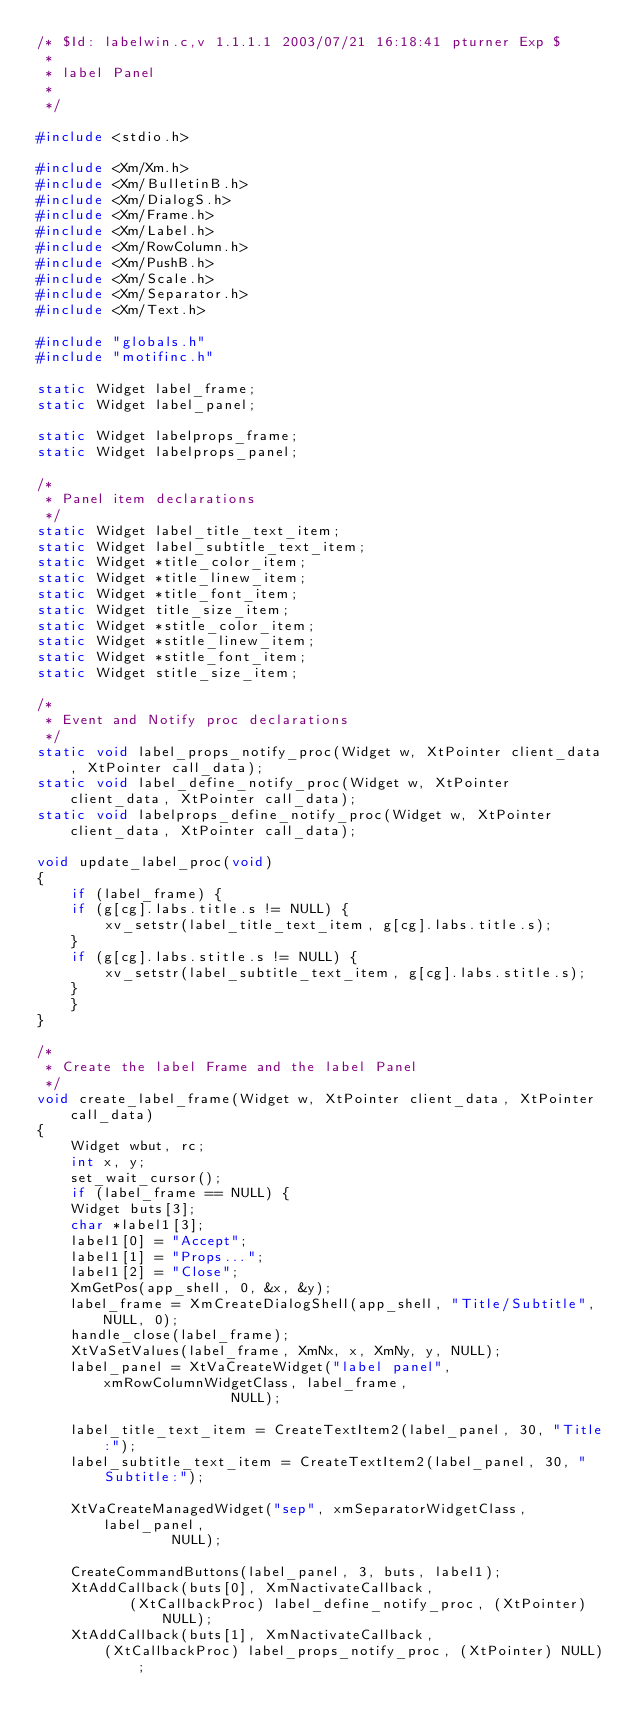<code> <loc_0><loc_0><loc_500><loc_500><_C_>/* $Id: labelwin.c,v 1.1.1.1 2003/07/21 16:18:41 pturner Exp $
 *
 * label Panel
 *
 */

#include <stdio.h>

#include <Xm/Xm.h>
#include <Xm/BulletinB.h>
#include <Xm/DialogS.h>
#include <Xm/Frame.h>
#include <Xm/Label.h>
#include <Xm/RowColumn.h>
#include <Xm/PushB.h>
#include <Xm/Scale.h>
#include <Xm/Separator.h>
#include <Xm/Text.h>

#include "globals.h"
#include "motifinc.h"

static Widget label_frame;
static Widget label_panel;

static Widget labelprops_frame;
static Widget labelprops_panel;

/*
 * Panel item declarations
 */
static Widget label_title_text_item;
static Widget label_subtitle_text_item;
static Widget *title_color_item;
static Widget *title_linew_item;
static Widget *title_font_item;
static Widget title_size_item;
static Widget *stitle_color_item;
static Widget *stitle_linew_item;
static Widget *stitle_font_item;
static Widget stitle_size_item;

/*
 * Event and Notify proc declarations
 */
static void label_props_notify_proc(Widget w, XtPointer client_data, XtPointer call_data);
static void label_define_notify_proc(Widget w, XtPointer client_data, XtPointer call_data);
static void labelprops_define_notify_proc(Widget w, XtPointer client_data, XtPointer call_data);

void update_label_proc(void)
{
    if (label_frame) {
	if (g[cg].labs.title.s != NULL) {
	    xv_setstr(label_title_text_item, g[cg].labs.title.s);
	}
	if (g[cg].labs.stitle.s != NULL) {
	    xv_setstr(label_subtitle_text_item, g[cg].labs.stitle.s);
	}
    }
}

/*
 * Create the label Frame and the label Panel
 */
void create_label_frame(Widget w, XtPointer client_data, XtPointer call_data)
{
    Widget wbut, rc;
    int x, y;
    set_wait_cursor();
    if (label_frame == NULL) {
	Widget buts[3];
	char *label1[3];
	label1[0] = "Accept";
	label1[1] = "Props...";
	label1[2] = "Close";
	XmGetPos(app_shell, 0, &x, &y);
	label_frame = XmCreateDialogShell(app_shell, "Title/Subtitle", NULL, 0);
	handle_close(label_frame);
	XtVaSetValues(label_frame, XmNx, x, XmNy, y, NULL);
	label_panel = XtVaCreateWidget("label panel", xmRowColumnWidgetClass, label_frame,
				       NULL);

	label_title_text_item = CreateTextItem2(label_panel, 30, "Title:");
	label_subtitle_text_item = CreateTextItem2(label_panel, 30, "Subtitle:");

	XtVaCreateManagedWidget("sep", xmSeparatorWidgetClass, label_panel,
				NULL);

	CreateCommandButtons(label_panel, 3, buts, label1);
	XtAddCallback(buts[0], XmNactivateCallback,
	       (XtCallbackProc) label_define_notify_proc, (XtPointer) NULL);
	XtAddCallback(buts[1], XmNactivateCallback,
		(XtCallbackProc) label_props_notify_proc, (XtPointer) NULL);</code> 